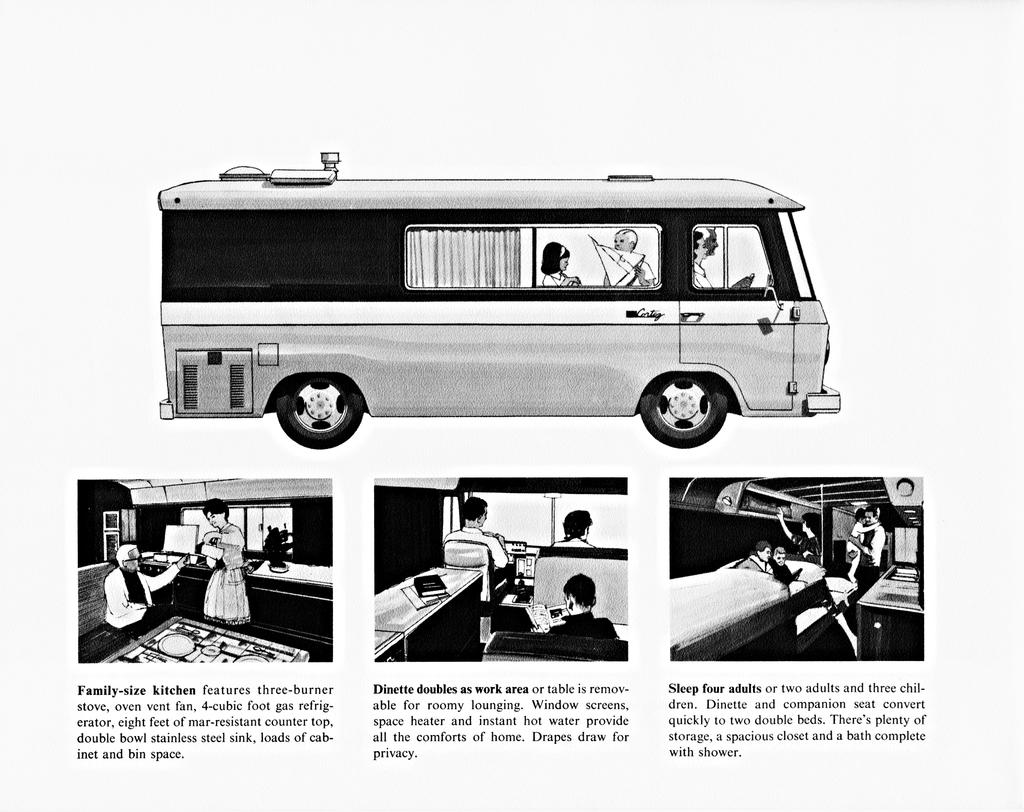What doubles as a work area?
Give a very brief answer. Dinette. 